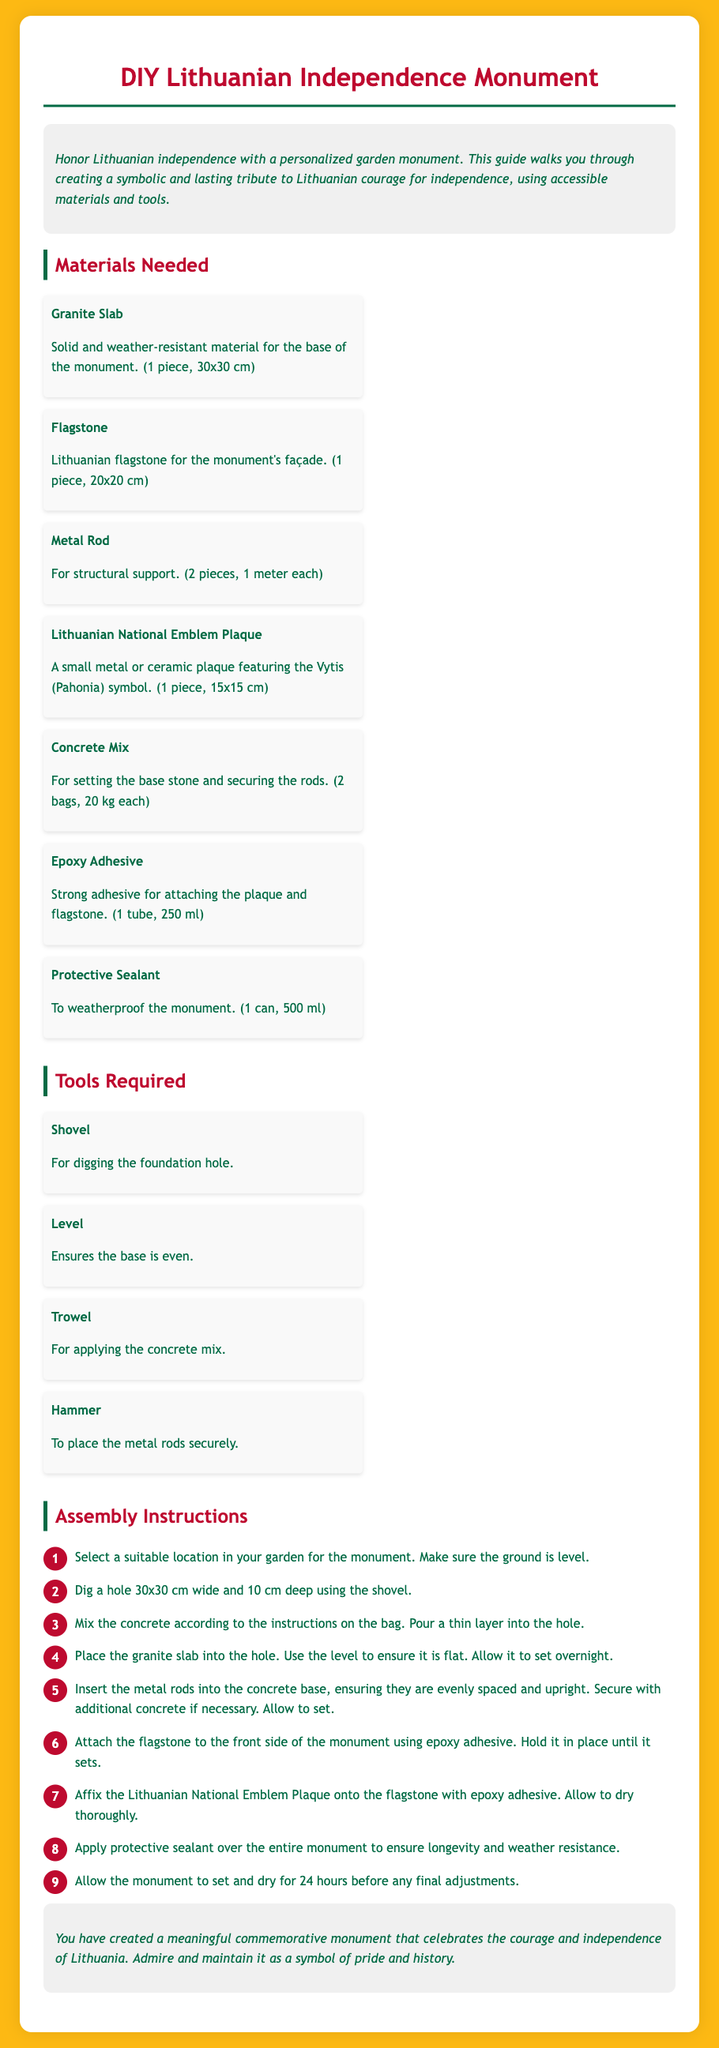What material is used for the base of the monument? The base of the monument is made from a granite slab.
Answer: Granite Slab How deep should the hole be dug for the monument? According to the instructions, the hole should be 10 cm deep.
Answer: 10 cm How many pieces of flagstone are needed? The instructions specify that only 1 piece of flagstone is required.
Answer: 1 piece What must be applied over the entire monument for weather resistance? The document mentions applying protective sealant over the monument.
Answer: Protective Sealant What is the first step in the assembly instructions? The first step requires selecting a suitable location in the garden for the monument.
Answer: Select a suitable location How many bags of concrete mix are needed? The instructions indicate that 2 bags of concrete mix are required.
Answer: 2 bags What symbol features on the Lithuanian National Emblem Plaque? The plaque features the Vytis (Pahonia) symbol.
Answer: Vytis (Pahonia) What should be used to ensure the foundation is level? A level should be used to ensure the base is even.
Answer: Level What is the recommended drying time before making final adjustments? The document states to allow the monument to set and dry for 24 hours.
Answer: 24 hours 